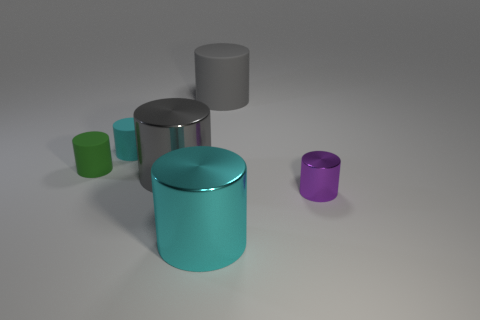What is the material of the small cyan cylinder? rubber 